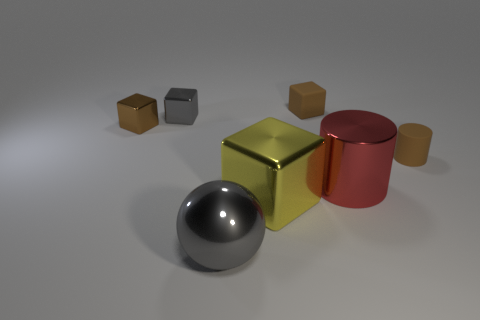Is the cylinder in front of the tiny matte cylinder made of the same material as the yellow block?
Provide a succinct answer. Yes. How many tiny things are shiny cylinders or brown objects?
Provide a succinct answer. 3. How big is the brown metal block?
Offer a very short reply. Small. Does the yellow object have the same size as the brown matte object that is in front of the tiny brown matte cube?
Offer a terse response. No. What number of brown objects are either large rubber things or tiny matte blocks?
Keep it short and to the point. 1. What number of big gray balls are there?
Ensure brevity in your answer.  1. There is a brown thing on the left side of the big gray object; what size is it?
Make the answer very short. Small. Is the gray sphere the same size as the rubber cylinder?
Offer a very short reply. No. What number of objects are brown rubber cylinders or brown things that are in front of the gray block?
Offer a terse response. 2. What material is the red object?
Your answer should be very brief. Metal. 